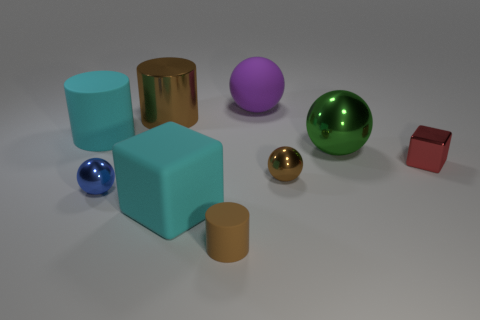The large brown thing is what shape?
Offer a very short reply. Cylinder. What size is the shiny cylinder that is the same color as the small matte cylinder?
Make the answer very short. Large. There is a metal ball left of the large metallic thing that is left of the cyan matte block; how big is it?
Keep it short and to the point. Small. There is a cyan rubber object left of the small blue object; what size is it?
Provide a succinct answer. Large. Are there fewer big cyan rubber cylinders that are in front of the purple thing than red metal cubes that are left of the small blue ball?
Provide a short and direct response. No. The small block is what color?
Provide a succinct answer. Red. Are there any big metallic cylinders of the same color as the tiny cylinder?
Your answer should be compact. Yes. There is a tiny red shiny object that is behind the small ball that is in front of the tiny metallic sphere that is to the right of the blue shiny sphere; what shape is it?
Your response must be concise. Cube. What material is the big cylinder that is to the right of the small blue shiny object?
Keep it short and to the point. Metal. There is a cyan matte object that is behind the tiny ball that is on the left side of the large cyan rubber thing that is to the right of the big cyan cylinder; what is its size?
Make the answer very short. Large. 